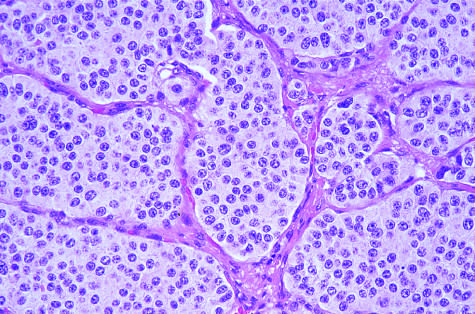what does the histologic appearance demonstrate?
Answer the question using a single word or phrase. Small 